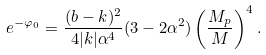<formula> <loc_0><loc_0><loc_500><loc_500>e ^ { - \varphi _ { 0 } } = \frac { ( b - k ) ^ { 2 } } { 4 | k | \alpha ^ { 4 } } ( 3 - 2 \alpha ^ { 2 } ) \left ( \frac { M _ { p } } { M } \right ) ^ { 4 } .</formula> 